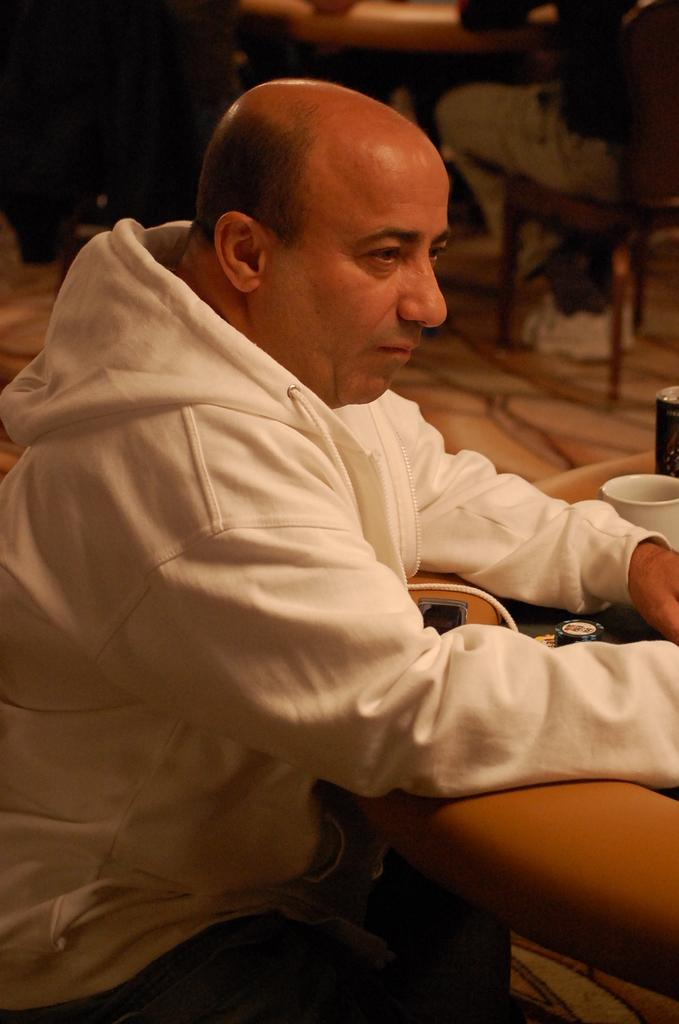What is the man in the image doing? The man is sitting in the image. What is in front of the man? There is a cup in front of the man. What can be seen on the table in the image? There are objects on a table in the image. Can you describe the person in the background? There is a person sitting on a chair in the background. What part of the room can be seen in the background? The floor is visible in the background. How many pages of a book can be seen in the image? There is no book or pages visible in the image. Are there any spiders crawling on the man in the image? There are no spiders present in the image. 